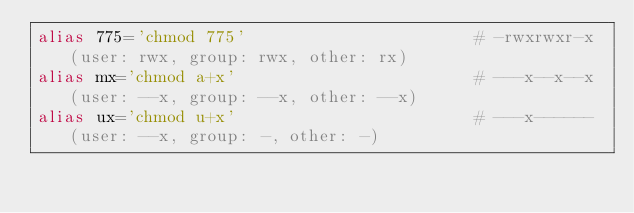Convert code to text. <code><loc_0><loc_0><loc_500><loc_500><_Bash_>alias 775='chmod 775'                       # -rwxrwxr-x (user: rwx, group: rwx, other: rx)
alias mx='chmod a+x'                        # ---x--x--x (user: --x, group: --x, other: --x)
alias ux='chmod u+x'                        # ---x------ (user: --x, group: -, other: -)
</code> 